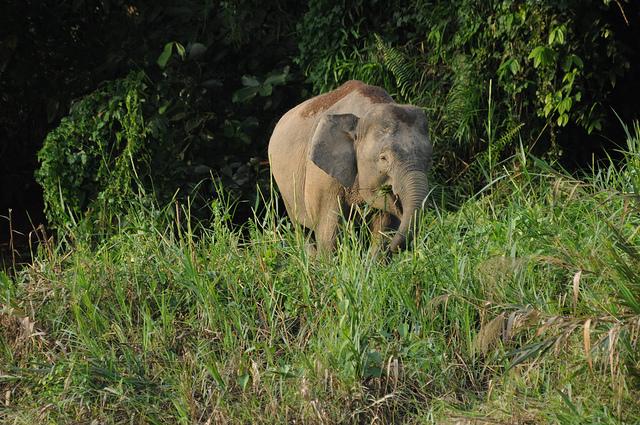Is the elephant drinking from a water source right now?
Give a very brief answer. No. What part of the animal is facing the photographer?
Be succinct. Head. What is beneath the elephant's trunk?
Write a very short answer. Grass. Why is there only 1 elephant in this picture?
Short answer required. My best guess is he came out of forest. Is the elephant coming or going?
Short answer required. Coming. 